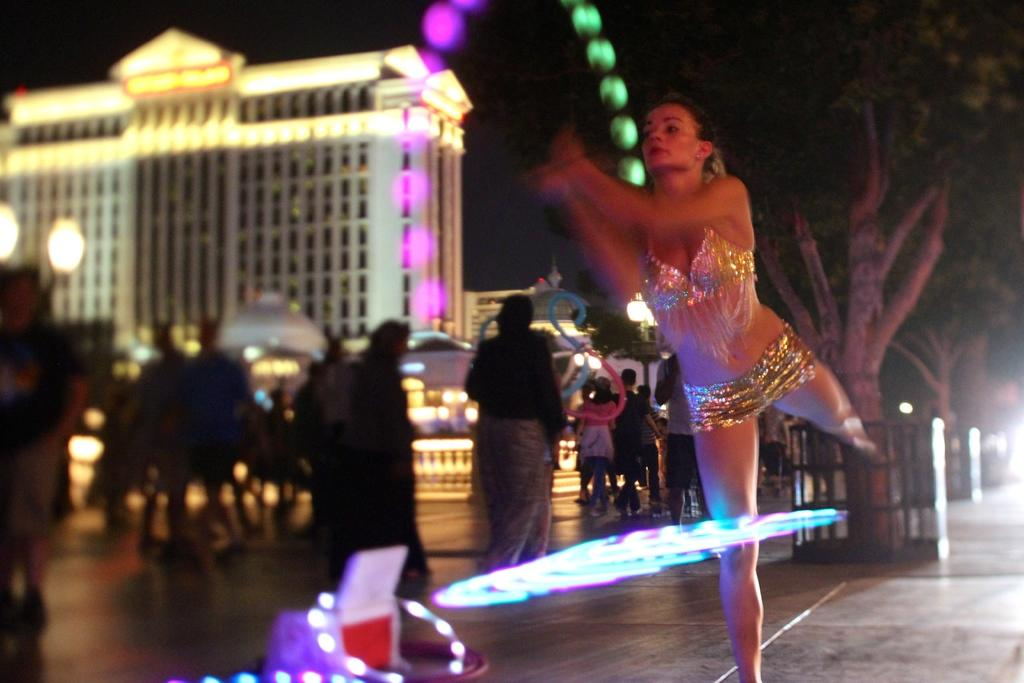What is the woman doing in the image? The woman is standing on the ground in the image. Who else is present in the image besides the woman? There is a group of people standing on the floor in the image. What natural element can be seen in the image? There is a tree in the image. What man-made structure is visible in the image? There is a building in the image. What source of illumination is present in the image? There is a light in the image. What route is the mother taking in the image? There is no mention of a mother or a route in the image; it only shows a woman and a group of people. 